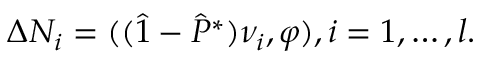<formula> <loc_0><loc_0><loc_500><loc_500>\Delta N _ { i } = ( ( \hat { 1 } - \hat { P } ^ { * } ) \nu _ { i } , \varphi ) , i = 1 , \dots , l .</formula> 